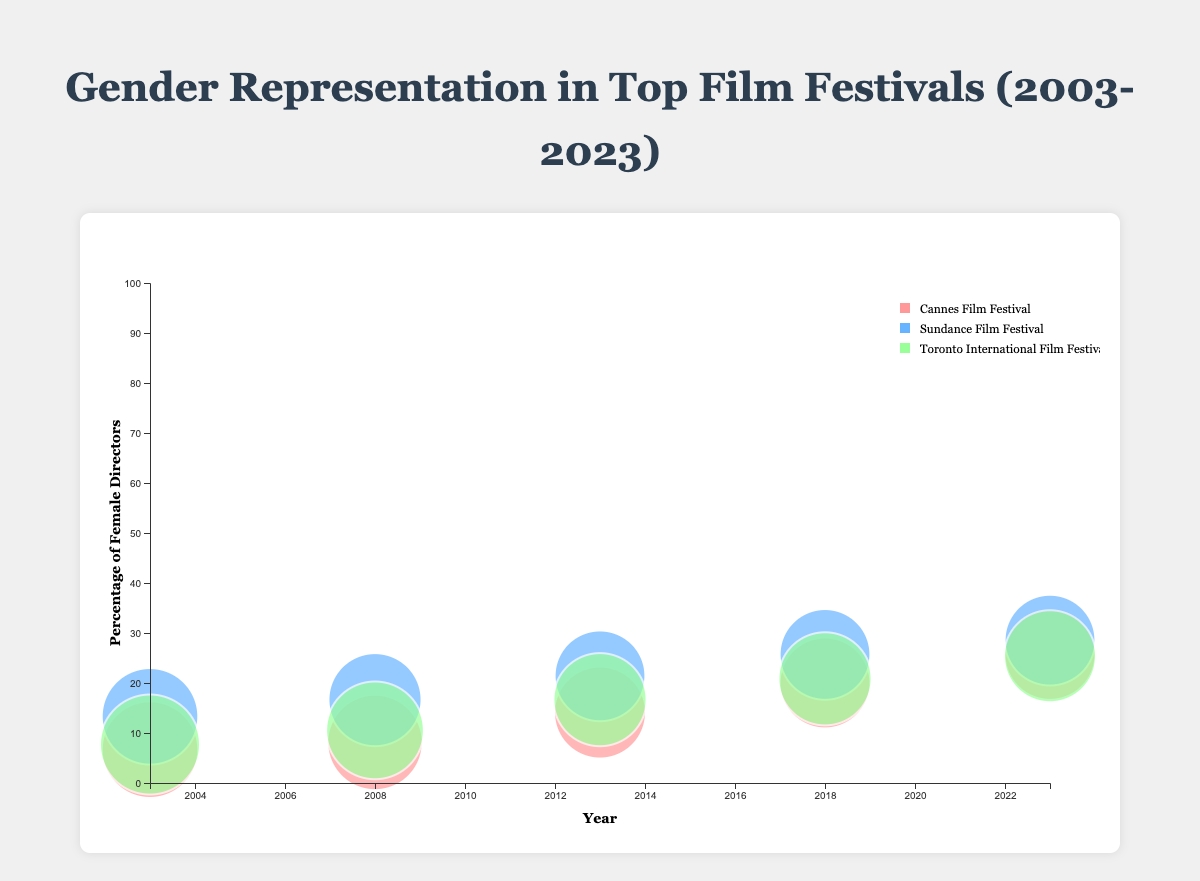Which film festival has the largest bubble in 2023? The bubble size represents the total number of directors. In 2023, the largest bubble belongs to the Cannes Film Festival with 70 total directors.
Answer: Cannes Film Festival What is the percentage of female directors at Sundance Film Festival in 2013? The percentage of female directors is calculated by dividing the number of female directors by the total number of directors and then multiplying by 100. For Sundance Film Festival in 2013, it is (15 / 70) * 100.
Answer: 21.43% Between 2003 and 2023, which film festival shows the greatest increase in the percentage of female directors? To find the greatest increase, subtract the 2003 percentage of female directors from the 2023 percentage for each film festival and compare the results. Sundance Film Festival shows the greatest increase, from (10/75) * 100 in 2003 to (20/70) * 100 in 2023.
Answer: Sundance Film Festival How does the representation of non-binary directors in 2023 compare across the film festivals? The Toronto International Film Festival has 3 non-binary directors, whereas Sundance has 5, and Cannes has 2 in 2023. This means Toronto has fewer non-binary directors than Sundance but more than Cannes.
Answer: Toronto < Sundance > Cannes What trend can be observed in the percentage of female directors for the Toronto International Film Festival from 2003 to 2023? The percentage of female directors at Toronto International Film Festival has generally increased over the years: 
2003: (6/78) * 100 = 7.69%, 
2008: (8/76) * 100 = 10.53%, 
2013: (12/72) * 100 = 16.67%, 
2018: (15/72) * 100 = 20.83%, 
2023: (18/71) * 100 = 25.35%.
Answer: Increasing trend In which year did Cannes Film Festival have the highest percentage of female directors? Check each year and calculate the percentage of female directors to identify the maximum. For Cannes: 2003: (5/75) * 100, 2008: (6/74) * 100, 2013: (10/71) * 100, 2018: (14/70) * 100, 2023: (18/70) * 100. The highest percentage is in 2023.
Answer: 2023 How many data points represent the Sundance Film Festival in the chart? Each year from 2003 to 2023 is represented as a data point. Refer to each occurrence of the Sundance Film Festival from 2003 to 2023.
Answer: 5 Comparing 2018, which festival had the highest percentage of female directors? Calculate the percentage for each festival in 2018 and compare. For 2018: 
Cannes: (14/70) * 100 = 20%, 
Sundance: (18/70) * 100 = 25.71%, 
Toronto: (15/72) * 100 = 20.83%.
Answer: Sundance Film Festival 